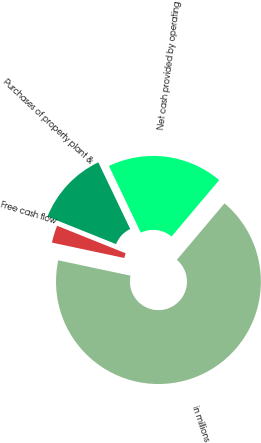Convert chart to OTSL. <chart><loc_0><loc_0><loc_500><loc_500><pie_chart><fcel>in millions<fcel>Net cash provided by operating<fcel>Purchases of property plant &<fcel>Free cash flow<nl><fcel>67.18%<fcel>18.26%<fcel>11.82%<fcel>2.74%<nl></chart> 